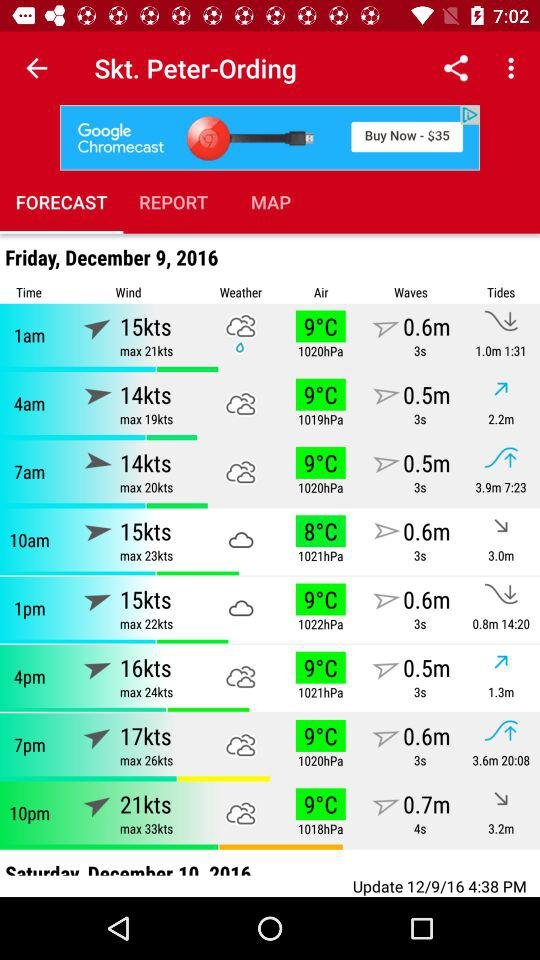What is the max wind speed for 10am?
Answer the question using a single word or phrase. 23kts 